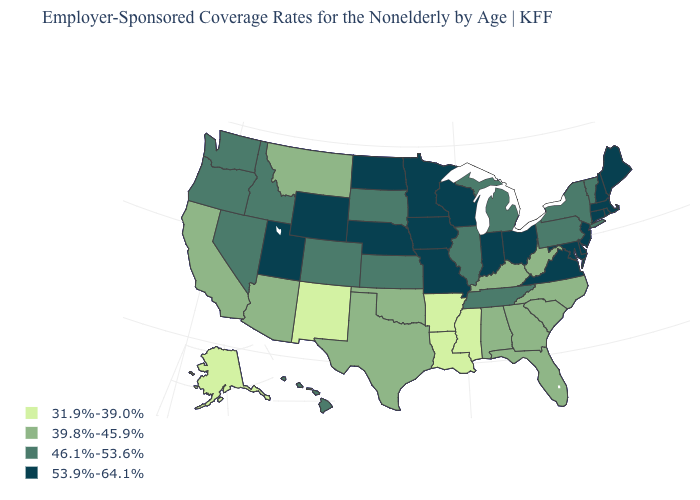Does Maine have the highest value in the Northeast?
Give a very brief answer. Yes. Which states have the highest value in the USA?
Write a very short answer. Connecticut, Delaware, Indiana, Iowa, Maine, Maryland, Massachusetts, Minnesota, Missouri, Nebraska, New Hampshire, New Jersey, North Dakota, Ohio, Rhode Island, Utah, Virginia, Wisconsin, Wyoming. What is the lowest value in the USA?
Keep it brief. 31.9%-39.0%. What is the value of Connecticut?
Quick response, please. 53.9%-64.1%. Name the states that have a value in the range 53.9%-64.1%?
Concise answer only. Connecticut, Delaware, Indiana, Iowa, Maine, Maryland, Massachusetts, Minnesota, Missouri, Nebraska, New Hampshire, New Jersey, North Dakota, Ohio, Rhode Island, Utah, Virginia, Wisconsin, Wyoming. Does Massachusetts have the lowest value in the Northeast?
Keep it brief. No. Does Wyoming have a higher value than Rhode Island?
Short answer required. No. What is the highest value in states that border Minnesota?
Write a very short answer. 53.9%-64.1%. How many symbols are there in the legend?
Concise answer only. 4. What is the lowest value in the MidWest?
Answer briefly. 46.1%-53.6%. What is the value of Vermont?
Concise answer only. 46.1%-53.6%. What is the lowest value in the USA?
Give a very brief answer. 31.9%-39.0%. How many symbols are there in the legend?
Concise answer only. 4. Which states hav the highest value in the MidWest?
Answer briefly. Indiana, Iowa, Minnesota, Missouri, Nebraska, North Dakota, Ohio, Wisconsin. 